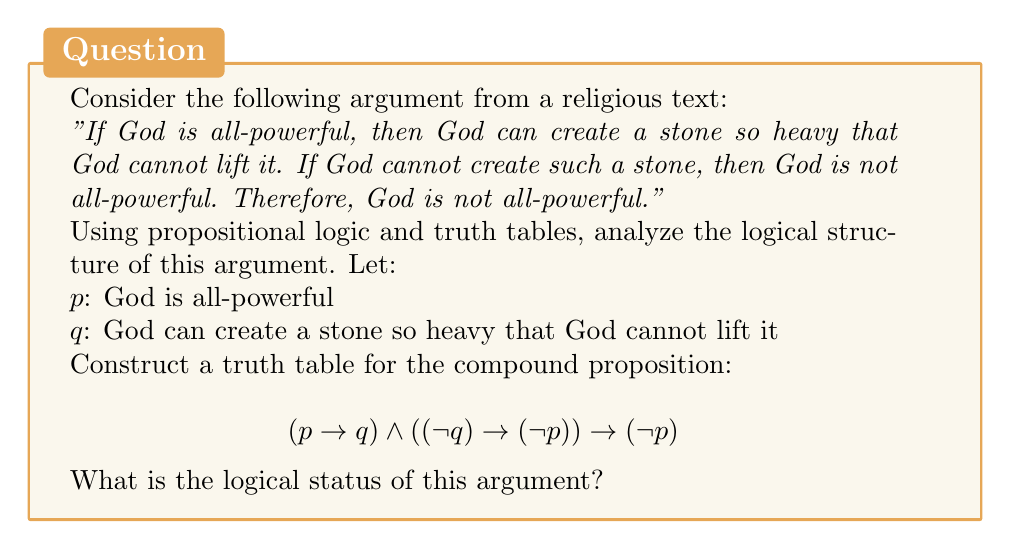Solve this math problem. To analyze the logical structure of this argument using a truth table, we'll follow these steps:

1) First, let's break down the compound proposition:
   $(p \rightarrow q)$ represents "If God is all-powerful, then God can create a stone so heavy that God cannot lift it"
   $((\lnot q) \rightarrow (\lnot p))$ represents "If God cannot create such a stone, then God is not all-powerful"
   $(\lnot p)$ represents the conclusion "God is not all-powerful"

2) Now, let's construct the truth table:

   | $p$ | $q$ | $p \rightarrow q$ | $\lnot q$ | $\lnot p$ | $(\lnot q) \rightarrow (\lnot p)$ | $(p \rightarrow q) \land ((\lnot q) \rightarrow (\lnot p))$ | $((p \rightarrow q) \land ((\lnot q) \rightarrow (\lnot p))) \rightarrow (\lnot p)$ |
   |-----|-----|-------------------|-----------|-----------|----------------------------------|---------------------------------------------------------|-----------------------------------------------------------------------------|
   | T   | T   | T                 | F         | F         | T                                | T                                                       | F                                                                           |
   | T   | F   | F                 | T         | F         | F                                | F                                                       | T                                                                           |
   | F   | T   | T                 | F         | T         | T                                | T                                                       | T                                                                           |
   | F   | F   | T                 | T         | T         | T                                | T                                                       | T                                                                           |

3) Analyzing the final column:
   The compound proposition is true in 3 out of 4 cases, but it's false when both $p$ and $q$ are true.

4) In propositional logic, an argument is considered valid if and only if its conclusion is true in every case where all its premises are true. In this truth table, we see that there's one case (when $p$ and $q$ are both true) where the premises are true but the conclusion is false.

5) Therefore, this argument is not logically valid. It commits the fallacy of denying the antecedent in its second premise.

From a Unitarian Universalist perspective, this analysis demonstrates the importance of critically examining religious arguments and being open to diverse interpretations. It shows that even seemingly persuasive arguments can have logical flaws, encouraging a more nuanced and inclusive approach to religious discourse.
Answer: The argument is not logically valid. 